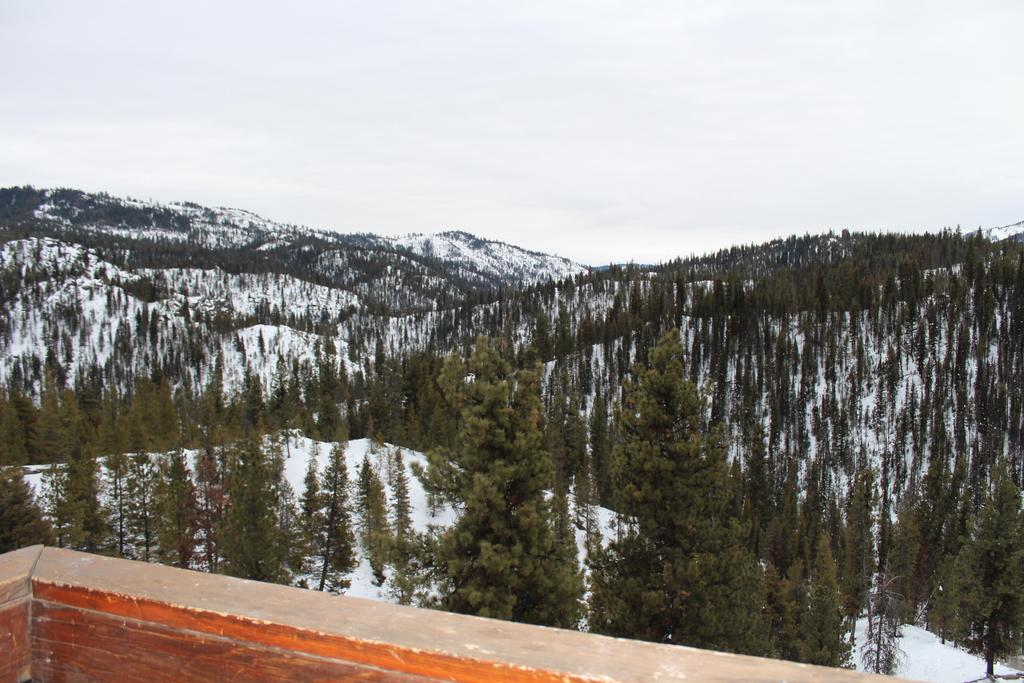What is located on the left side of the image? There is a wall on the left side of the image. What can be seen in the background of the image? Hills are visible in the background of the image. How are the hills described in the image? The hills are covered with trees and have snow on them. What is visible at the top of the image? The sky is visible at the top of the image. What type of lunch is being prepared in the image? There is no lunch preparation visible in the image; it features a wall, hills, trees, snow, and the sky. How does the image change when viewed from a different angle? The image does not change when viewed from a different angle, as it is a static representation. 